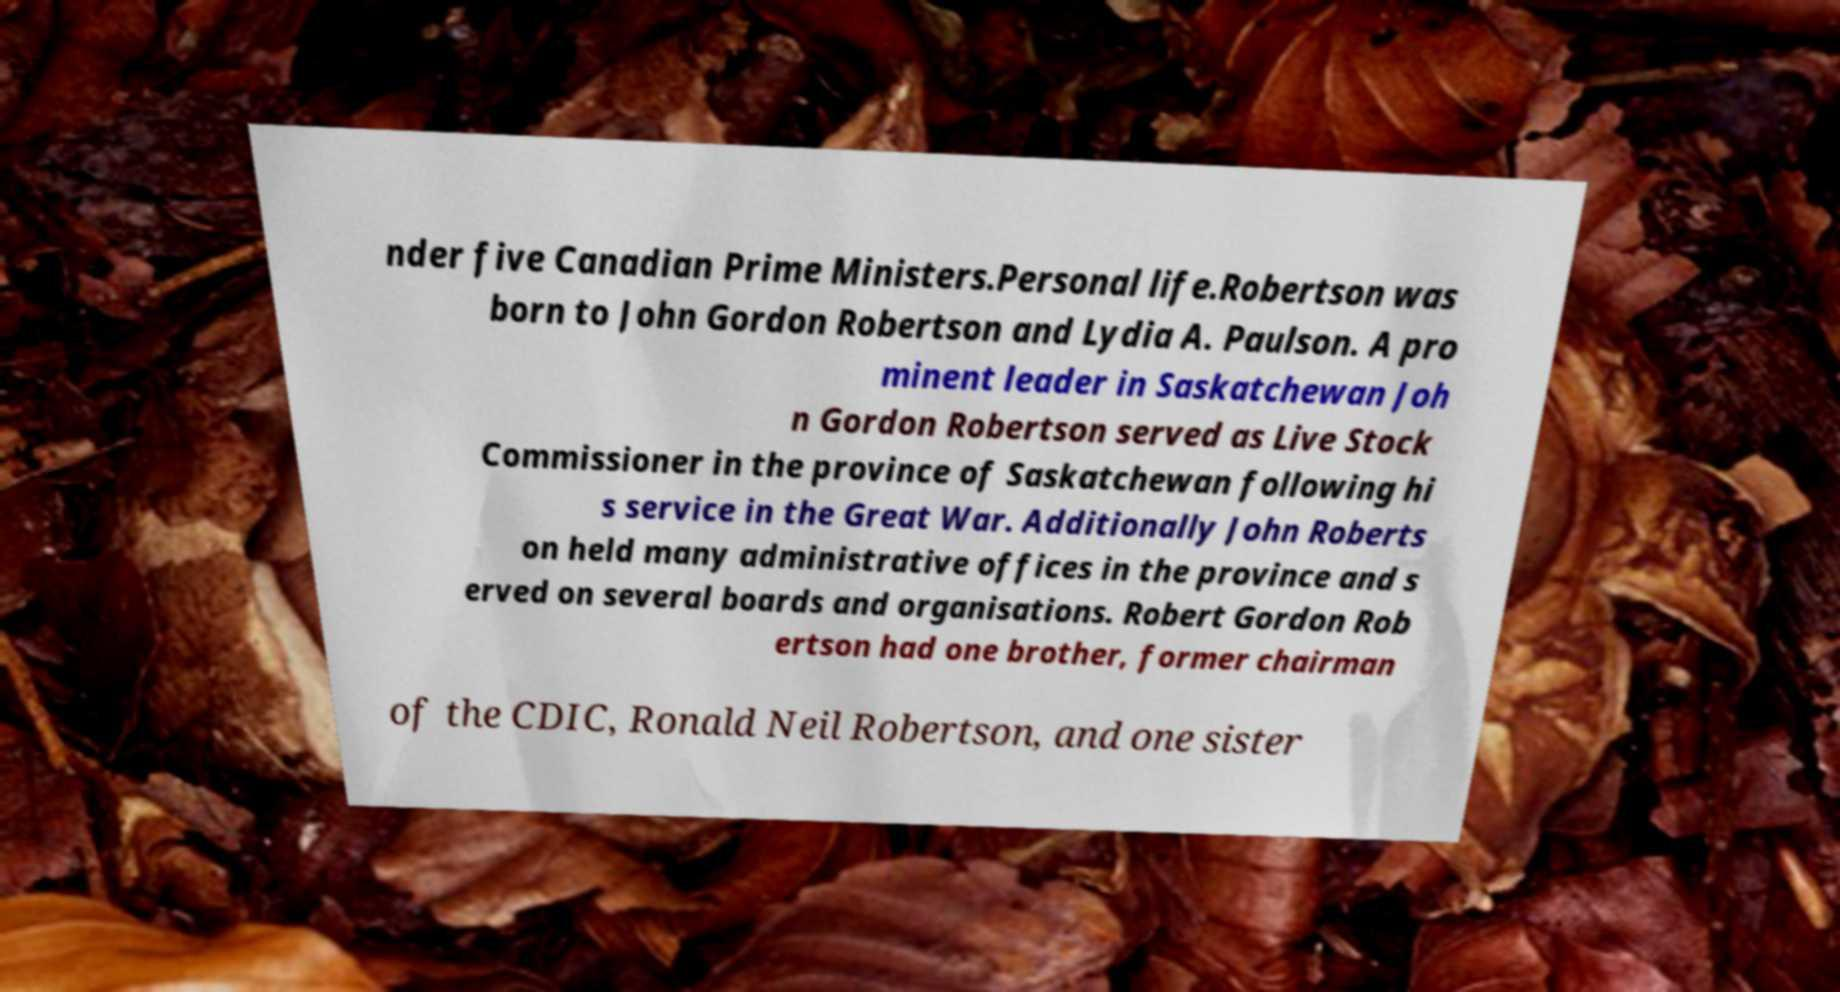I need the written content from this picture converted into text. Can you do that? nder five Canadian Prime Ministers.Personal life.Robertson was born to John Gordon Robertson and Lydia A. Paulson. A pro minent leader in Saskatchewan Joh n Gordon Robertson served as Live Stock Commissioner in the province of Saskatchewan following hi s service in the Great War. Additionally John Roberts on held many administrative offices in the province and s erved on several boards and organisations. Robert Gordon Rob ertson had one brother, former chairman of the CDIC, Ronald Neil Robertson, and one sister 